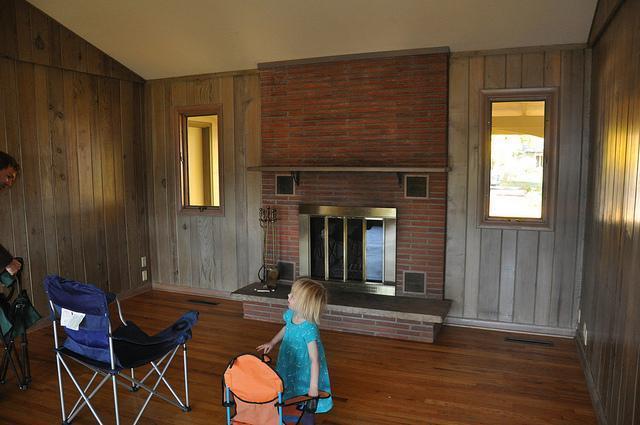How many chairs are there?
Give a very brief answer. 2. How many dogs is this?
Give a very brief answer. 0. 